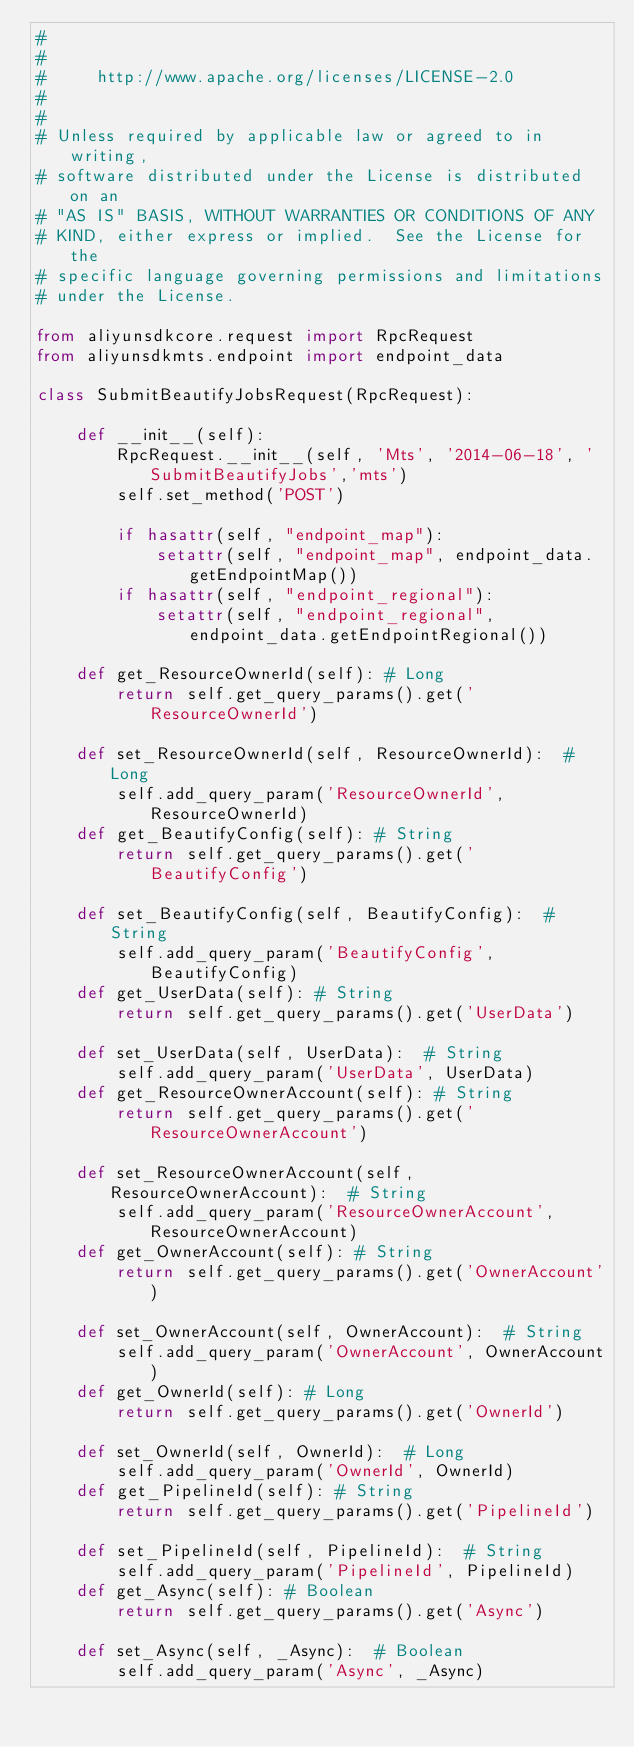<code> <loc_0><loc_0><loc_500><loc_500><_Python_>#
#
#     http://www.apache.org/licenses/LICENSE-2.0
#
#
# Unless required by applicable law or agreed to in writing,
# software distributed under the License is distributed on an
# "AS IS" BASIS, WITHOUT WARRANTIES OR CONDITIONS OF ANY
# KIND, either express or implied.  See the License for the
# specific language governing permissions and limitations
# under the License.

from aliyunsdkcore.request import RpcRequest
from aliyunsdkmts.endpoint import endpoint_data

class SubmitBeautifyJobsRequest(RpcRequest):

	def __init__(self):
		RpcRequest.__init__(self, 'Mts', '2014-06-18', 'SubmitBeautifyJobs','mts')
		self.set_method('POST')

		if hasattr(self, "endpoint_map"):
			setattr(self, "endpoint_map", endpoint_data.getEndpointMap())
		if hasattr(self, "endpoint_regional"):
			setattr(self, "endpoint_regional", endpoint_data.getEndpointRegional())

	def get_ResourceOwnerId(self): # Long
		return self.get_query_params().get('ResourceOwnerId')

	def set_ResourceOwnerId(self, ResourceOwnerId):  # Long
		self.add_query_param('ResourceOwnerId', ResourceOwnerId)
	def get_BeautifyConfig(self): # String
		return self.get_query_params().get('BeautifyConfig')

	def set_BeautifyConfig(self, BeautifyConfig):  # String
		self.add_query_param('BeautifyConfig', BeautifyConfig)
	def get_UserData(self): # String
		return self.get_query_params().get('UserData')

	def set_UserData(self, UserData):  # String
		self.add_query_param('UserData', UserData)
	def get_ResourceOwnerAccount(self): # String
		return self.get_query_params().get('ResourceOwnerAccount')

	def set_ResourceOwnerAccount(self, ResourceOwnerAccount):  # String
		self.add_query_param('ResourceOwnerAccount', ResourceOwnerAccount)
	def get_OwnerAccount(self): # String
		return self.get_query_params().get('OwnerAccount')

	def set_OwnerAccount(self, OwnerAccount):  # String
		self.add_query_param('OwnerAccount', OwnerAccount)
	def get_OwnerId(self): # Long
		return self.get_query_params().get('OwnerId')

	def set_OwnerId(self, OwnerId):  # Long
		self.add_query_param('OwnerId', OwnerId)
	def get_PipelineId(self): # String
		return self.get_query_params().get('PipelineId')

	def set_PipelineId(self, PipelineId):  # String
		self.add_query_param('PipelineId', PipelineId)
	def get_Async(self): # Boolean
		return self.get_query_params().get('Async')

	def set_Async(self, _Async):  # Boolean
		self.add_query_param('Async', _Async)
</code> 